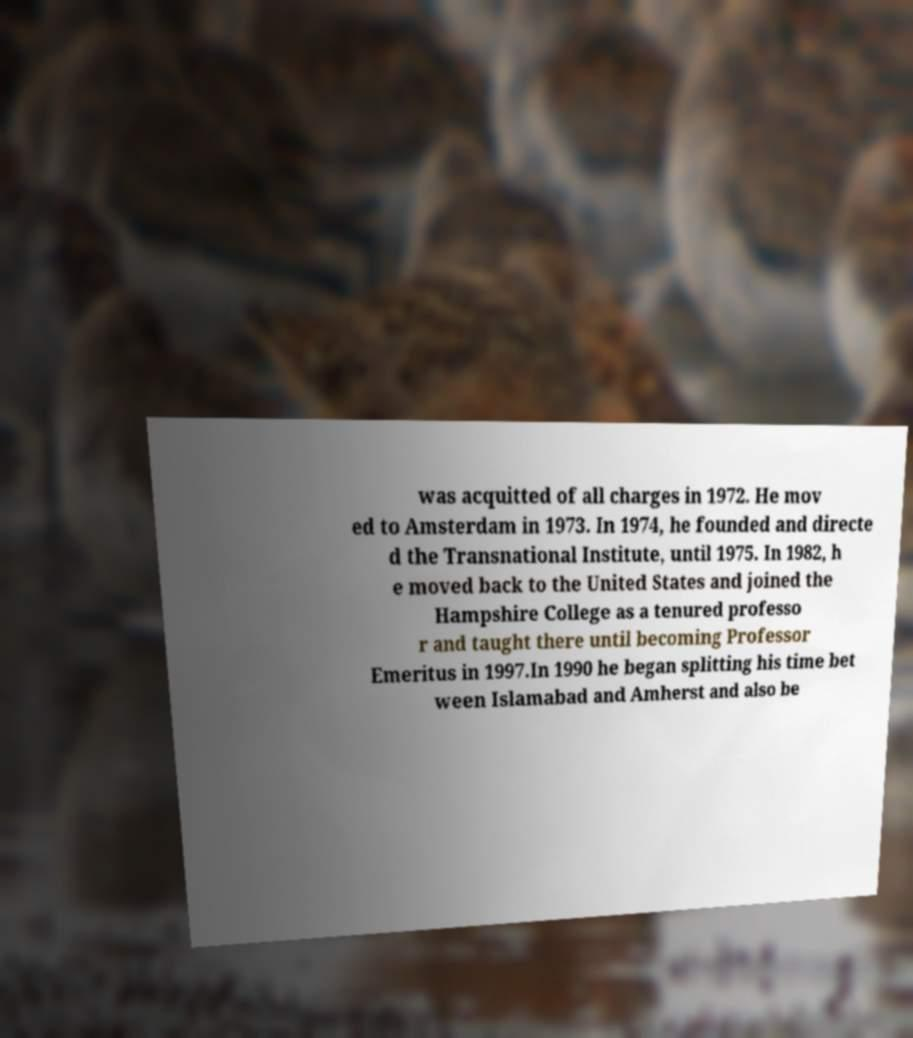Please identify and transcribe the text found in this image. was acquitted of all charges in 1972. He mov ed to Amsterdam in 1973. In 1974, he founded and directe d the Transnational Institute, until 1975. In 1982, h e moved back to the United States and joined the Hampshire College as a tenured professo r and taught there until becoming Professor Emeritus in 1997.In 1990 he began splitting his time bet ween Islamabad and Amherst and also be 